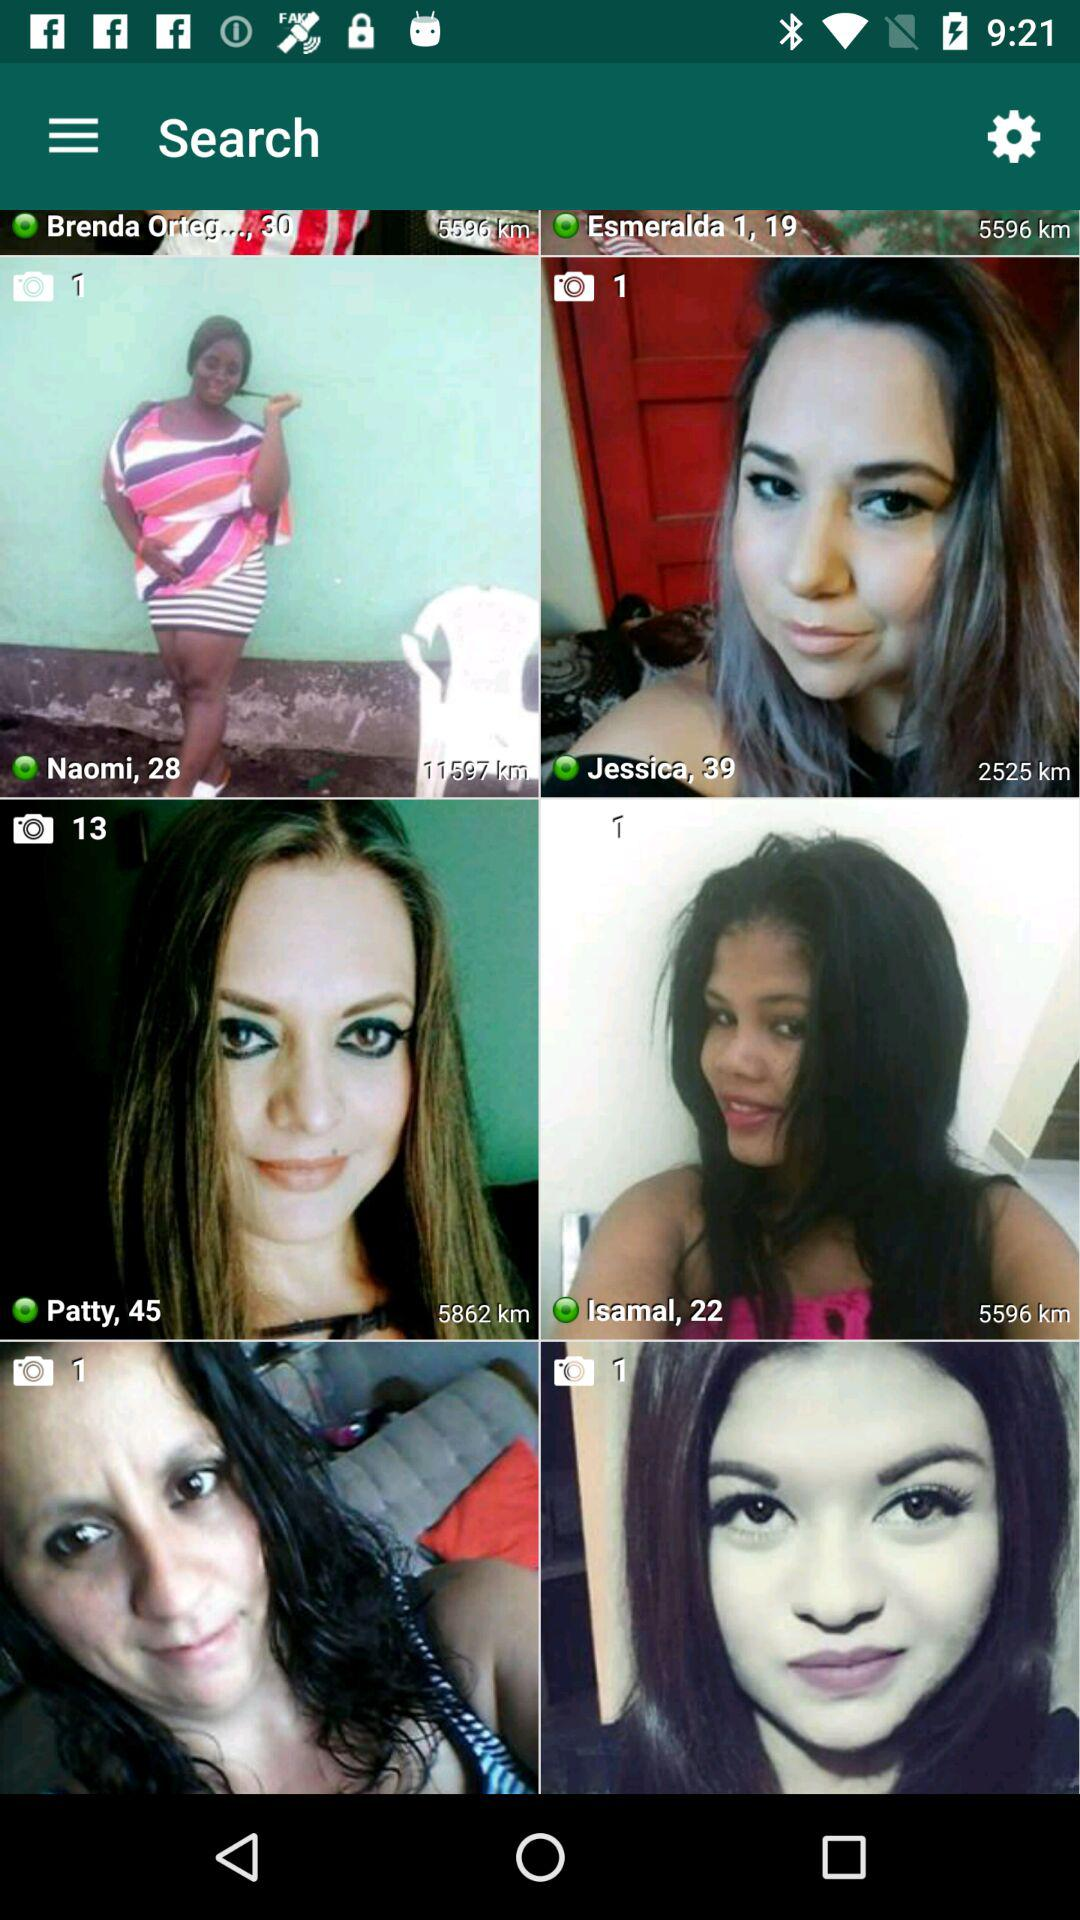What is the age of Naomi? The age of Naomi is 28. 